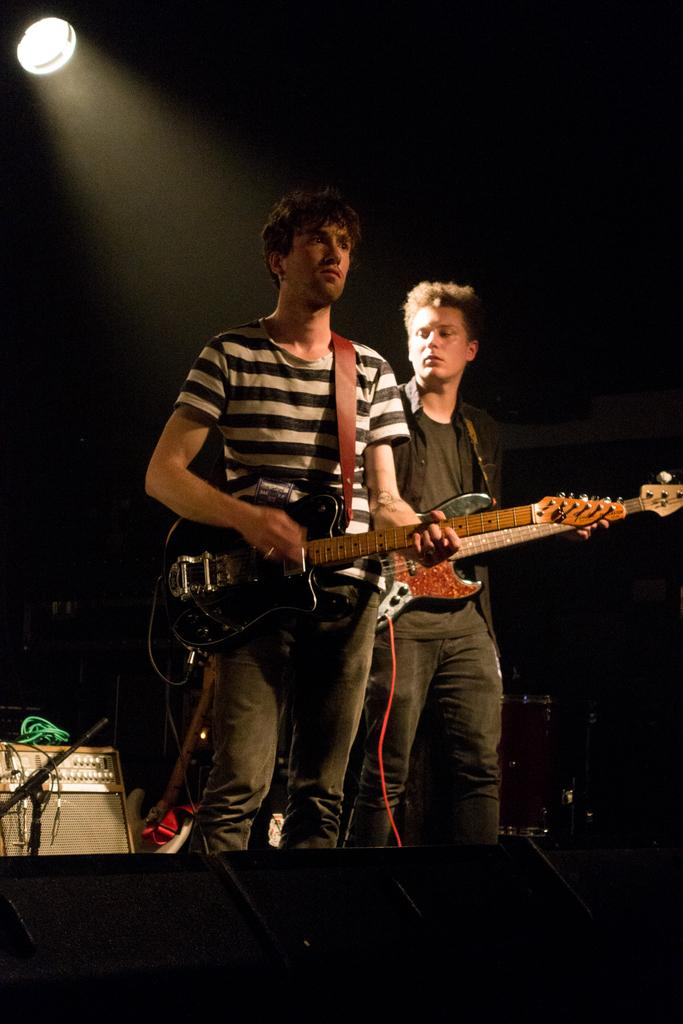How many people are in the image? There are two men in the image. Where are the men located in the image? The men are standing on a stage. What are the men doing in the image? The men are playing guitars. What other musical instruments can be seen in the image? There are other musical instruments present in the image. What is the source of light in the image? There is a light at the top of the image. What type of flower is being used as a magic wand by one of the men in the image? There is no flower or magic wand present in the image; the men are playing guitars and there are other musical instruments visible. 